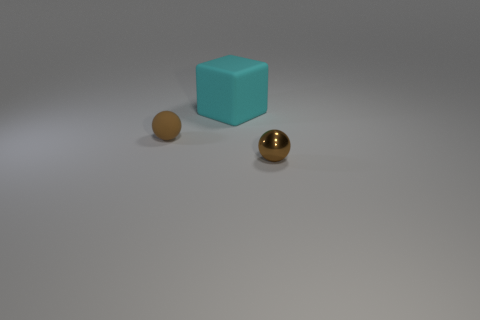Add 3 brown shiny things. How many objects exist? 6 Subtract all balls. How many objects are left? 1 Add 3 brown things. How many brown things exist? 5 Subtract 0 purple balls. How many objects are left? 3 Subtract all large cyan rubber blocks. Subtract all cyan cubes. How many objects are left? 1 Add 1 rubber balls. How many rubber balls are left? 2 